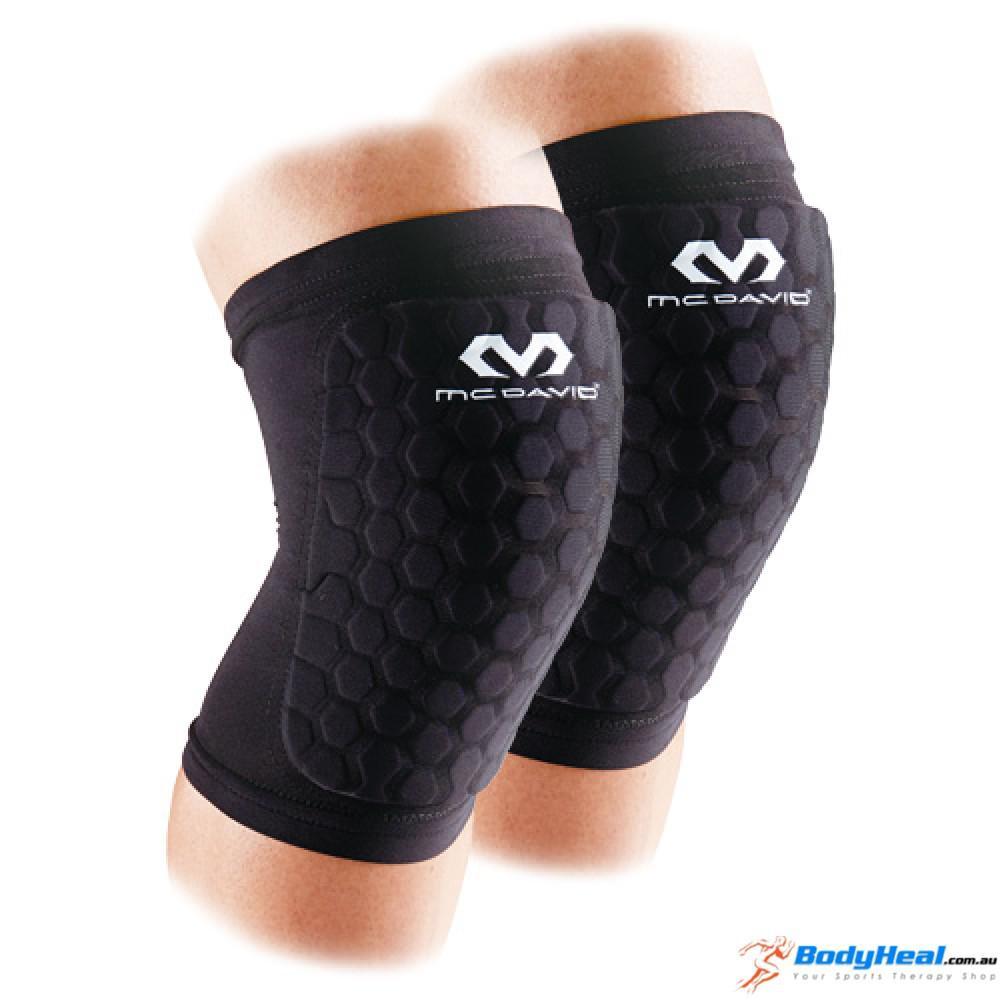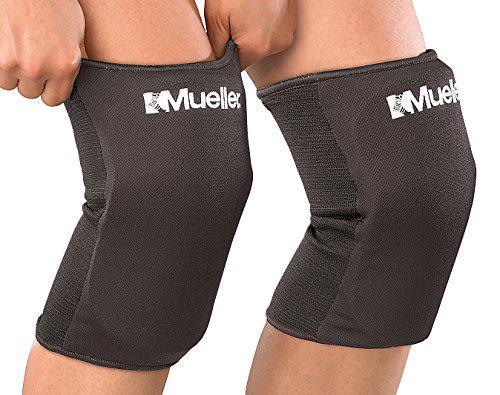The first image is the image on the left, the second image is the image on the right. Examine the images to the left and right. Is the description "There are two legs in the image on the right." accurate? Answer yes or no. Yes. 